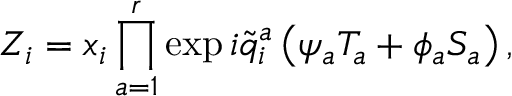Convert formula to latex. <formula><loc_0><loc_0><loc_500><loc_500>Z _ { i } = x _ { i } \prod _ { a = 1 } ^ { r } \exp i \widetilde { q } _ { i } ^ { a } \left ( \psi _ { a } T _ { a } + \phi _ { a } S _ { a } \right ) ,</formula> 